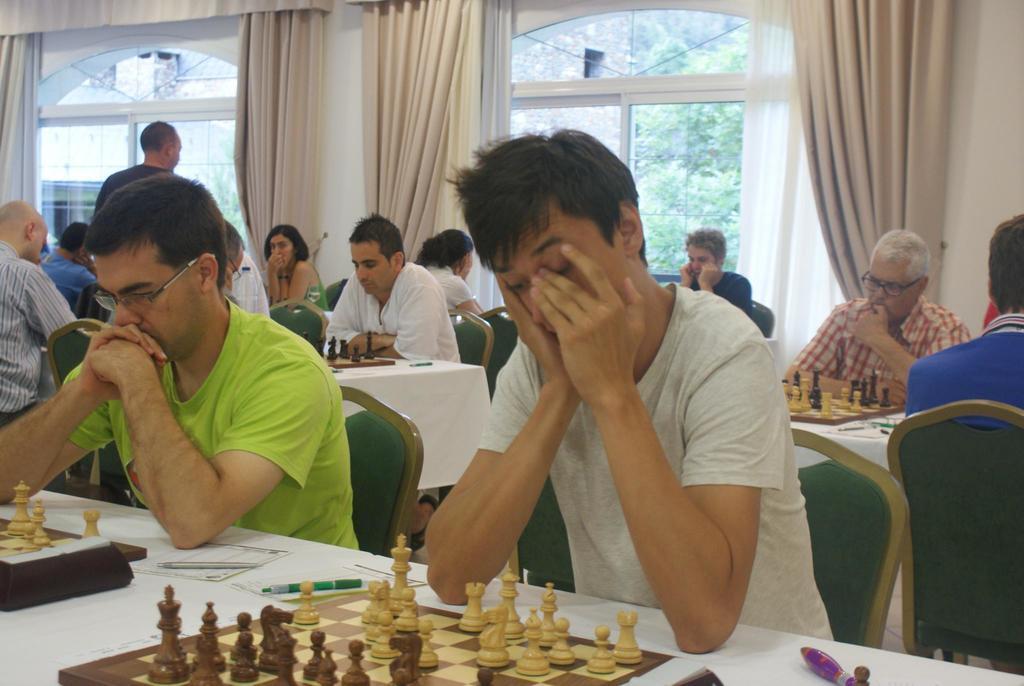Could you give a brief overview of what you see in this image? In this picture there are group of people those who are sitting on the chairs around the table and there is a chess boards on the table, there are windows around the area of the image with white curtains and all the people are playing the game called chess. 